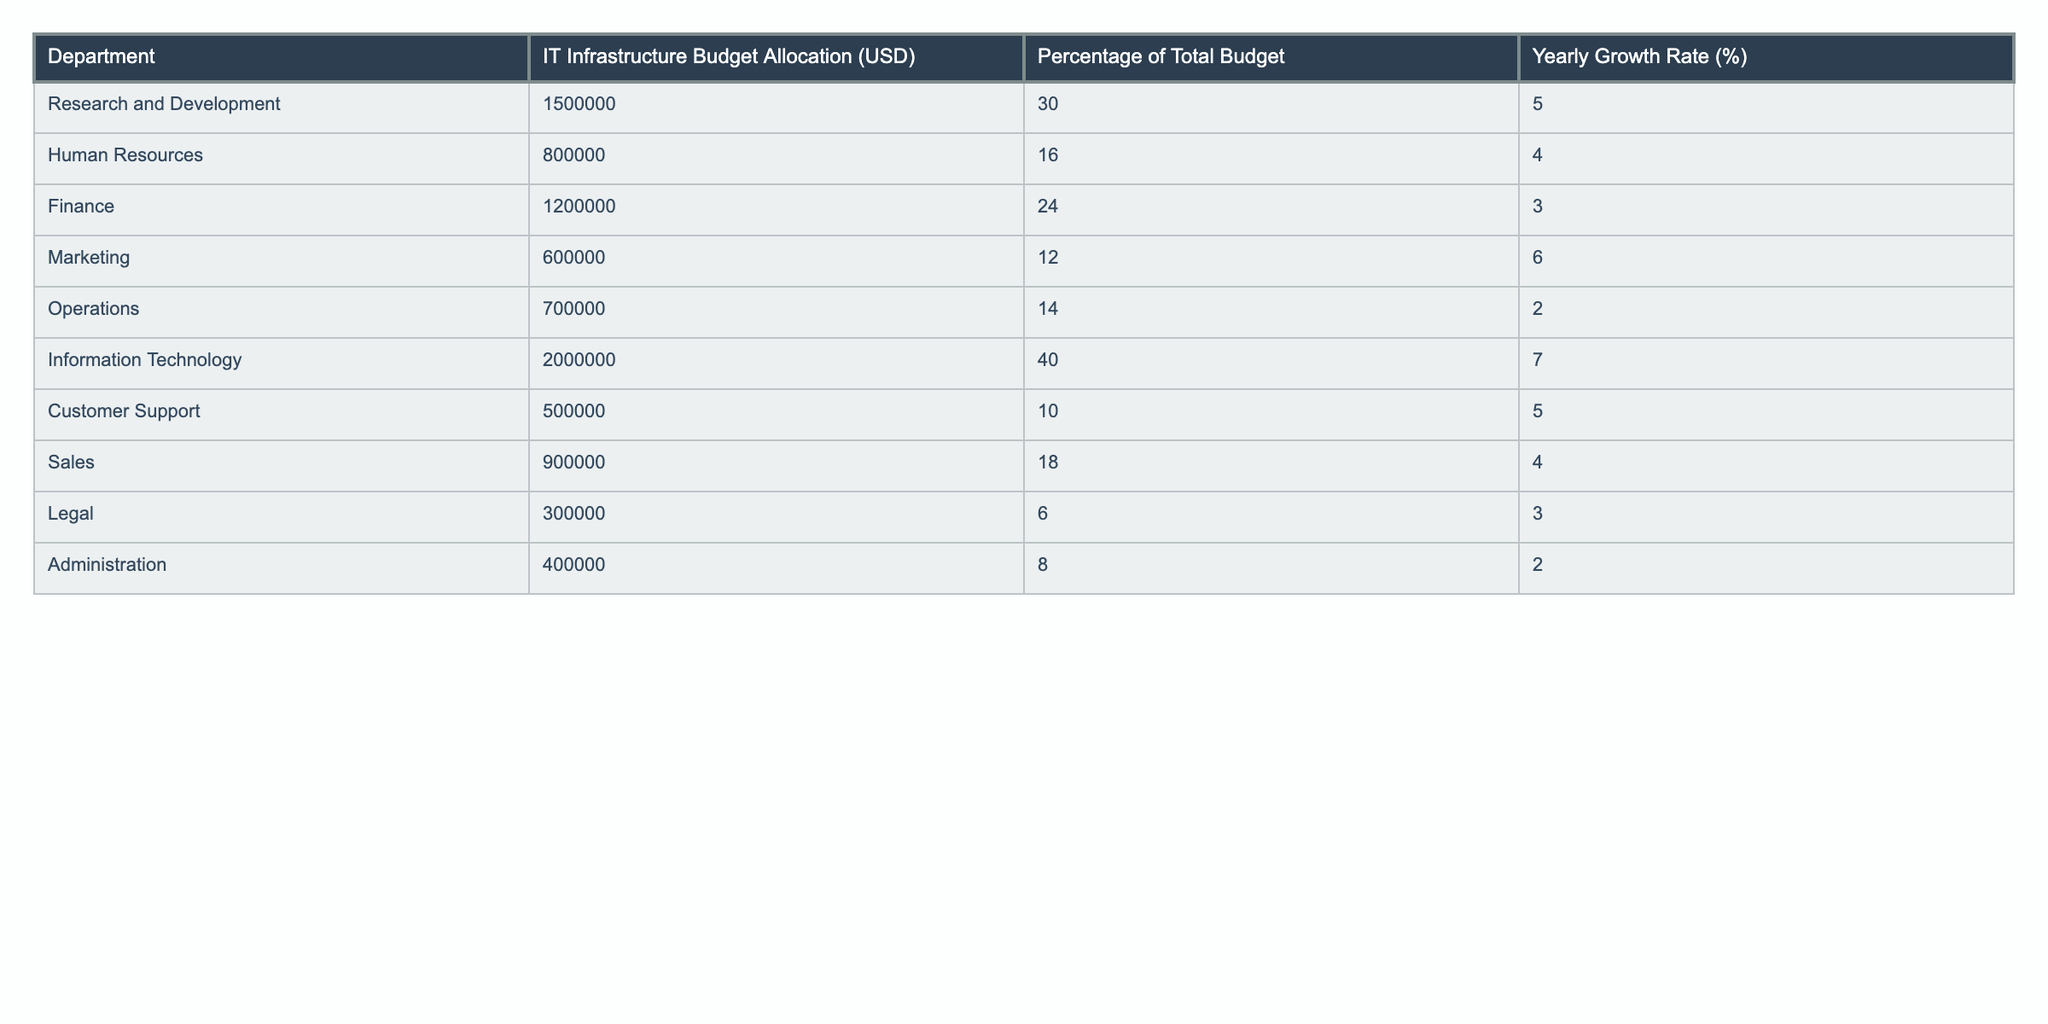What is the IT infrastructure budget allocated to the Information Technology department? According to the table, the specific budget for the Information Technology department is listed as 2,000,000 USD.
Answer: 2,000,000 USD Which department has the largest percentage of the total budget allocation? The table shows that the Information Technology department has the largest percentage of total budget allocation, which is 40%.
Answer: 40% What is the combined budget allocation for Human Resources and Legal departments? The budget for Human Resources is 800,000 USD, and for Legal, it is 300,000 USD. Adding these gives 800,000 + 300,000 = 1,100,000 USD.
Answer: 1,100,000 USD Is the yearly growth rate for the Marketing department higher than that of Customer Support? The yearly growth rate for Marketing is 6%, while for Customer Support it is 5%. Since 6% is greater than 5%, the statement is true.
Answer: Yes What is the average IT infrastructure budget allocation across all departments? There are 10 departments, and the total budget allocation can be summed up as 1,500,000 + 800,000 + 1,200,000 + 600,000 + 700,000 + 2,000,000 + 500,000 + 900,000 + 300,000 + 400,000 = 8,600,000 USD. Dividing this by 10 gives an average of 860,000 USD.
Answer: 860,000 USD Which department has the lowest IT infrastructure budget allocation? The table indicates that the Legal department has the lowest allocation, which is 300,000 USD.
Answer: 300,000 USD If we consider a total budget allocation of 5,000,000 USD, which department contributes the least percentage of the total budget? To find this, we calculate the percentage contributions of each department: Human Resources = (800,000 / 5,000,000) * 100 = 16%, Legal = (300,000 / 5,000,000) * 100 = 6%. Since 6% is the lowest, the Legal department contributes the least percentage.
Answer: Legal department What is the total budget allocated to departments with a yearly growth rate higher than 5%? The departments with a yearly growth rate higher than 5% are Information Technology (7%), Research and Development (5%), and Marketing (6%). Their respective budgets are 2,000,000 + 1,500,000 + 600,000 = 4,100,000 USD.
Answer: 4,100,000 USD How much higher is the budget allocation for Finance compared to Operations? The budget for Finance is 1,200,000 USD and for Operations it is 700,000 USD. The difference is 1,200,000 - 700,000 = 500,000 USD.
Answer: 500,000 USD Is the total budget allocation for Departments starting with 'H' greater than the total for those starting with 'C'? The departments starting with 'H' are Human Resources (800,000 USD) and the one starting with 'C' is Customer Support (500,000 USD). The total for 'H' is 800,000 USD and for 'C' is 500,000 USD. Since 800,000 > 500,000, the statement is true.
Answer: Yes 